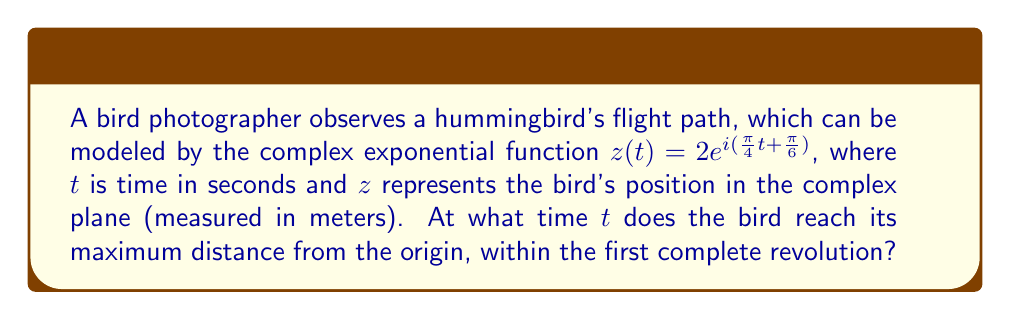Could you help me with this problem? Let's approach this step-by-step:

1) The given function is $z(t) = 2e^{i(\frac{\pi}{4}t + \frac{\pi}{6})}$

2) To find the distance from the origin, we need to calculate the magnitude of $z(t)$:
   $|z(t)| = |2e^{i(\frac{\pi}{4}t + \frac{\pi}{6})}| = 2|e^{i(\frac{\pi}{4}t + \frac{\pi}{6})}| = 2$

3) We see that the magnitude is constant at 2, regardless of $t$. This means the bird is always 2 meters from the origin.

4) For a complete revolution, we need the argument of the exponential to increase by $2\pi$:
   $\frac{\pi}{4}t + \frac{\pi}{6} = \frac{\pi}{6} + 2\pi$

5) Solving for $t$:
   $\frac{\pi}{4}t = 2\pi$
   $t = 8$ seconds

6) Since the distance is constant, any time within the first revolution (0 ≤ t < 8) gives the maximum distance.

7) For simplicity, we can choose $t = 0$ as our answer.
Answer: $t = 0$ s 